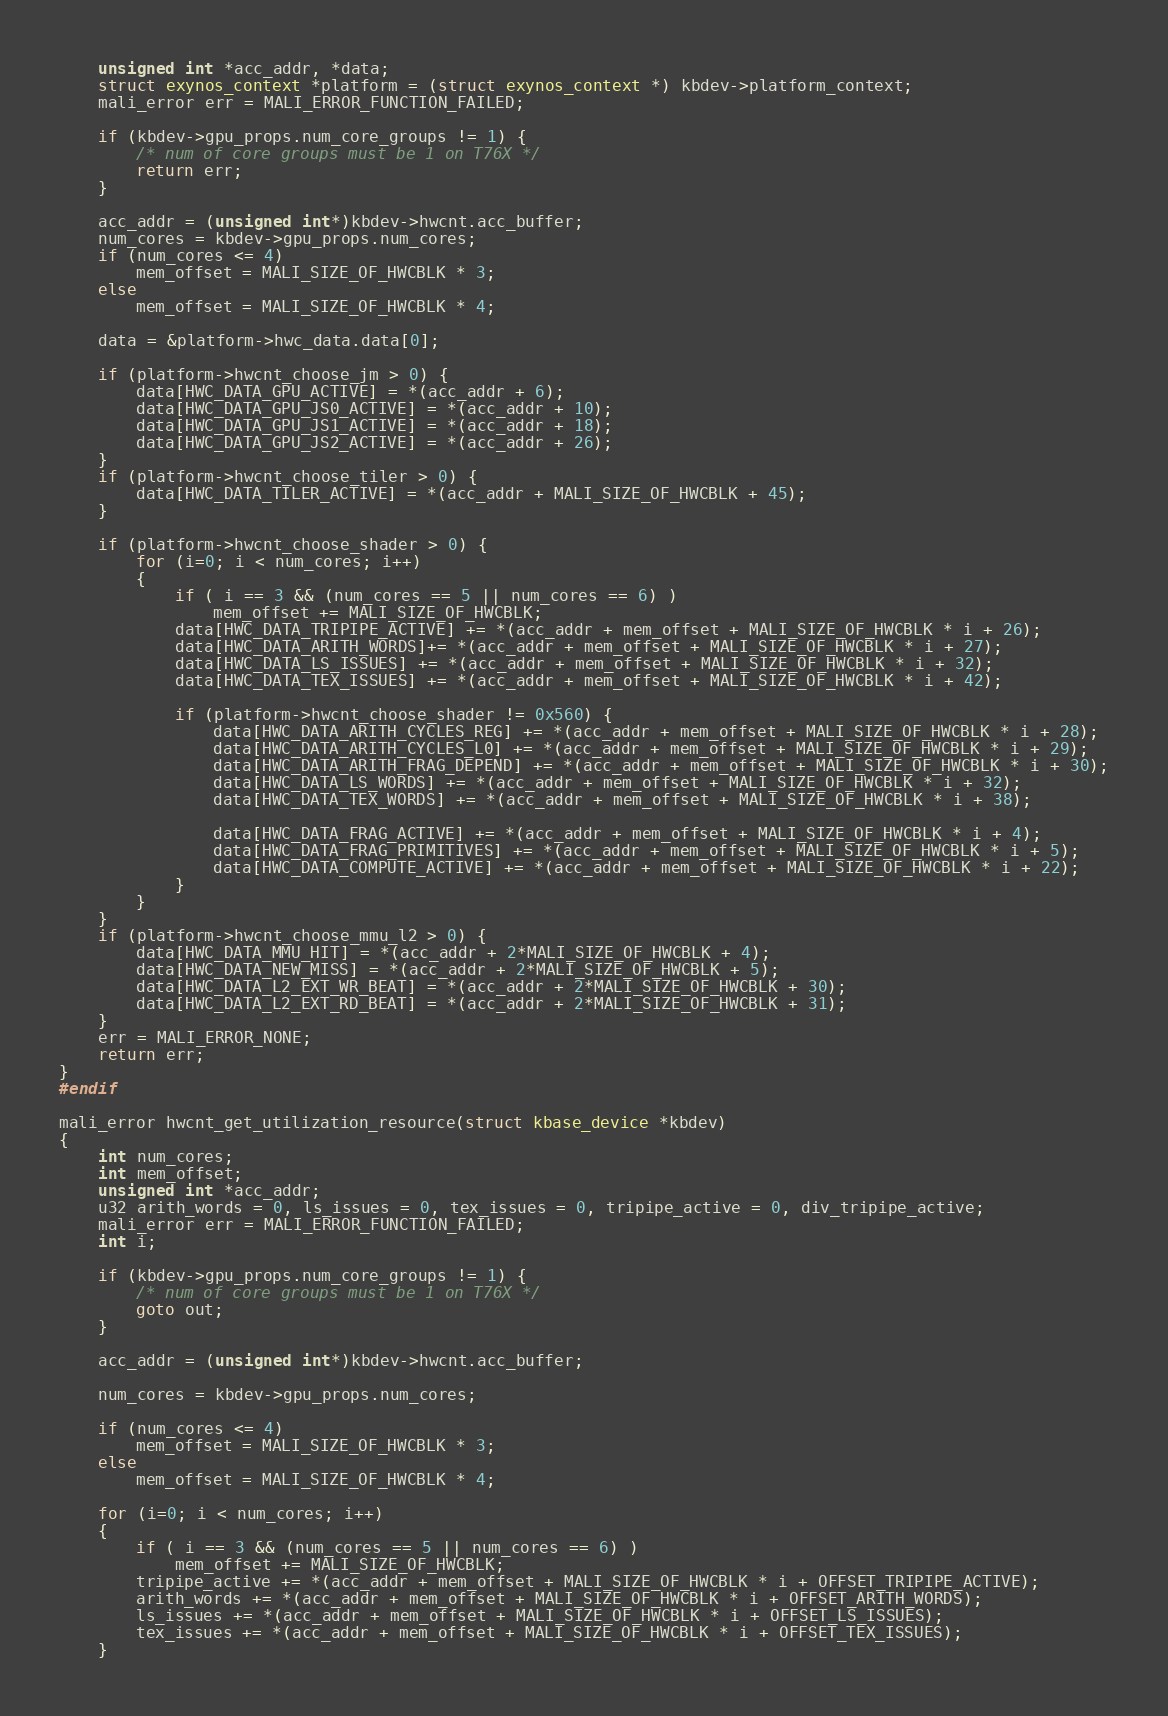Convert code to text. <code><loc_0><loc_0><loc_500><loc_500><_C_>	unsigned int *acc_addr, *data;
	struct exynos_context *platform = (struct exynos_context *) kbdev->platform_context;
	mali_error err = MALI_ERROR_FUNCTION_FAILED;

	if (kbdev->gpu_props.num_core_groups != 1) {
		/* num of core groups must be 1 on T76X */
		return err;
	}

	acc_addr = (unsigned int*)kbdev->hwcnt.acc_buffer;
	num_cores = kbdev->gpu_props.num_cores;
	if (num_cores <= 4)
		mem_offset = MALI_SIZE_OF_HWCBLK * 3;
	else
		mem_offset = MALI_SIZE_OF_HWCBLK * 4;

	data = &platform->hwc_data.data[0];

	if (platform->hwcnt_choose_jm > 0) {
		data[HWC_DATA_GPU_ACTIVE] = *(acc_addr + 6);
		data[HWC_DATA_GPU_JS0_ACTIVE] = *(acc_addr + 10);
		data[HWC_DATA_GPU_JS1_ACTIVE] = *(acc_addr + 18);
		data[HWC_DATA_GPU_JS2_ACTIVE] = *(acc_addr + 26);
	}
	if (platform->hwcnt_choose_tiler > 0) {
		data[HWC_DATA_TILER_ACTIVE] = *(acc_addr + MALI_SIZE_OF_HWCBLK + 45);
	}

	if (platform->hwcnt_choose_shader > 0) {
		for (i=0; i < num_cores; i++)
		{
			if ( i == 3 && (num_cores == 5 || num_cores == 6) )
				mem_offset += MALI_SIZE_OF_HWCBLK;
			data[HWC_DATA_TRIPIPE_ACTIVE] += *(acc_addr + mem_offset + MALI_SIZE_OF_HWCBLK * i + 26);
			data[HWC_DATA_ARITH_WORDS]+= *(acc_addr + mem_offset + MALI_SIZE_OF_HWCBLK * i + 27);
			data[HWC_DATA_LS_ISSUES] += *(acc_addr + mem_offset + MALI_SIZE_OF_HWCBLK * i + 32);
			data[HWC_DATA_TEX_ISSUES] += *(acc_addr + mem_offset + MALI_SIZE_OF_HWCBLK * i + 42);

			if (platform->hwcnt_choose_shader != 0x560) {
				data[HWC_DATA_ARITH_CYCLES_REG] += *(acc_addr + mem_offset + MALI_SIZE_OF_HWCBLK * i + 28);
				data[HWC_DATA_ARITH_CYCLES_L0] += *(acc_addr + mem_offset + MALI_SIZE_OF_HWCBLK * i + 29);
				data[HWC_DATA_ARITH_FRAG_DEPEND] += *(acc_addr + mem_offset + MALI_SIZE_OF_HWCBLK * i + 30);
				data[HWC_DATA_LS_WORDS] += *(acc_addr + mem_offset + MALI_SIZE_OF_HWCBLK * i + 32);
				data[HWC_DATA_TEX_WORDS] += *(acc_addr + mem_offset + MALI_SIZE_OF_HWCBLK * i + 38);

				data[HWC_DATA_FRAG_ACTIVE] += *(acc_addr + mem_offset + MALI_SIZE_OF_HWCBLK * i + 4);
				data[HWC_DATA_FRAG_PRIMITIVES] += *(acc_addr + mem_offset + MALI_SIZE_OF_HWCBLK * i + 5);
				data[HWC_DATA_COMPUTE_ACTIVE] += *(acc_addr + mem_offset + MALI_SIZE_OF_HWCBLK * i + 22);
			}
		}
	}
	if (platform->hwcnt_choose_mmu_l2 > 0) {
		data[HWC_DATA_MMU_HIT] = *(acc_addr + 2*MALI_SIZE_OF_HWCBLK + 4);
		data[HWC_DATA_NEW_MISS] = *(acc_addr + 2*MALI_SIZE_OF_HWCBLK + 5);
		data[HWC_DATA_L2_EXT_WR_BEAT] = *(acc_addr + 2*MALI_SIZE_OF_HWCBLK + 30);
		data[HWC_DATA_L2_EXT_RD_BEAT] = *(acc_addr + 2*MALI_SIZE_OF_HWCBLK + 31);
	}
	err = MALI_ERROR_NONE;
	return err;
}
#endif

mali_error hwcnt_get_utilization_resource(struct kbase_device *kbdev)
{
	int num_cores;
	int mem_offset;
	unsigned int *acc_addr;
	u32 arith_words = 0, ls_issues = 0, tex_issues = 0, tripipe_active = 0, div_tripipe_active;
	mali_error err = MALI_ERROR_FUNCTION_FAILED;
	int i;

	if (kbdev->gpu_props.num_core_groups != 1) {
		/* num of core groups must be 1 on T76X */
		goto out;
	}

	acc_addr = (unsigned int*)kbdev->hwcnt.acc_buffer;

	num_cores = kbdev->gpu_props.num_cores;

	if (num_cores <= 4)
		mem_offset = MALI_SIZE_OF_HWCBLK * 3;
	else
		mem_offset = MALI_SIZE_OF_HWCBLK * 4;

	for (i=0; i < num_cores; i++)
	{
		if ( i == 3 && (num_cores == 5 || num_cores == 6) )
			mem_offset += MALI_SIZE_OF_HWCBLK;
		tripipe_active += *(acc_addr + mem_offset + MALI_SIZE_OF_HWCBLK * i + OFFSET_TRIPIPE_ACTIVE);
		arith_words += *(acc_addr + mem_offset + MALI_SIZE_OF_HWCBLK * i + OFFSET_ARITH_WORDS);
		ls_issues += *(acc_addr + mem_offset + MALI_SIZE_OF_HWCBLK * i + OFFSET_LS_ISSUES);
		tex_issues += *(acc_addr + mem_offset + MALI_SIZE_OF_HWCBLK * i + OFFSET_TEX_ISSUES);
	}
</code> 